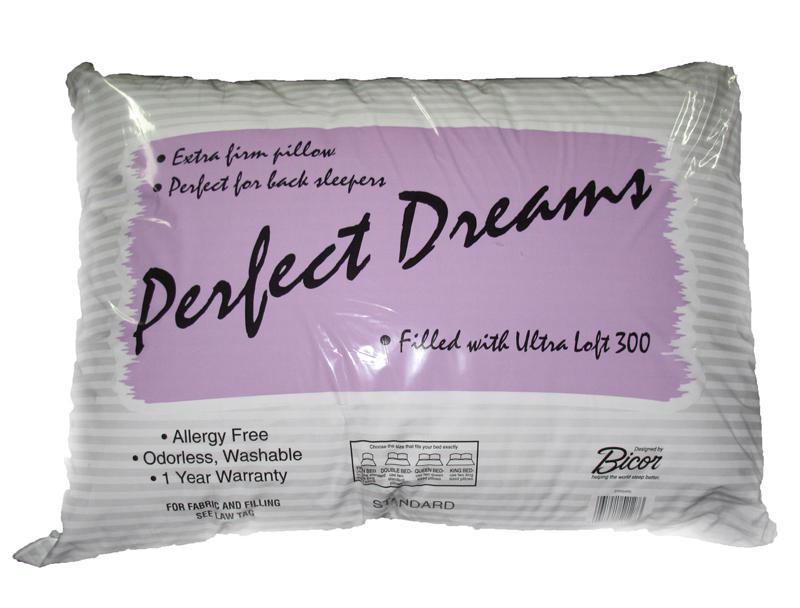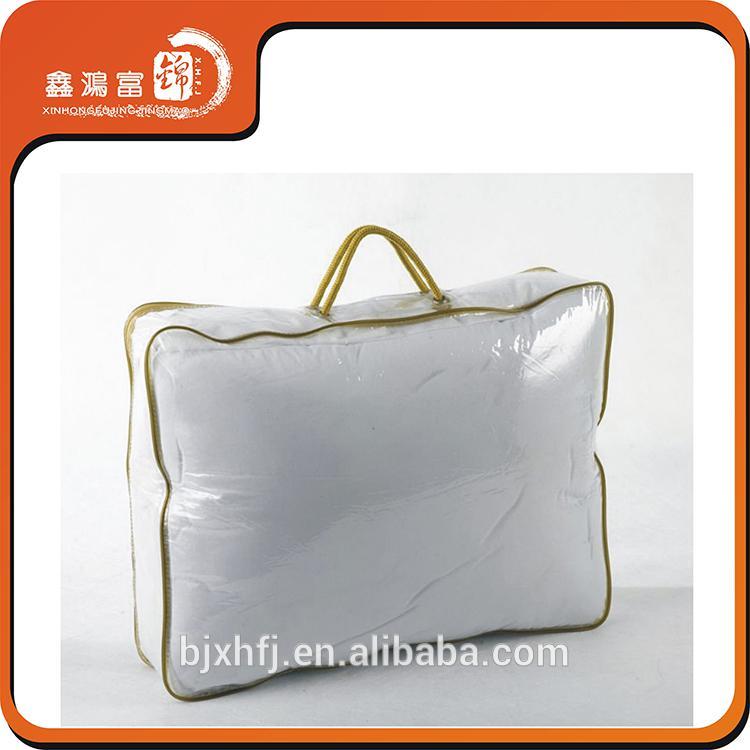The first image is the image on the left, the second image is the image on the right. Assess this claim about the two images: "Each image shows a pillow bag with at least one handle, and one image displays a bag head-on, while the other displays a bag at an angle.". Correct or not? Answer yes or no. No. The first image is the image on the left, the second image is the image on the right. Analyze the images presented: Is the assertion "In at least one image there is a pillow in a plastic zip bag that has gold plastic on the top fourth." valid? Answer yes or no. No. 